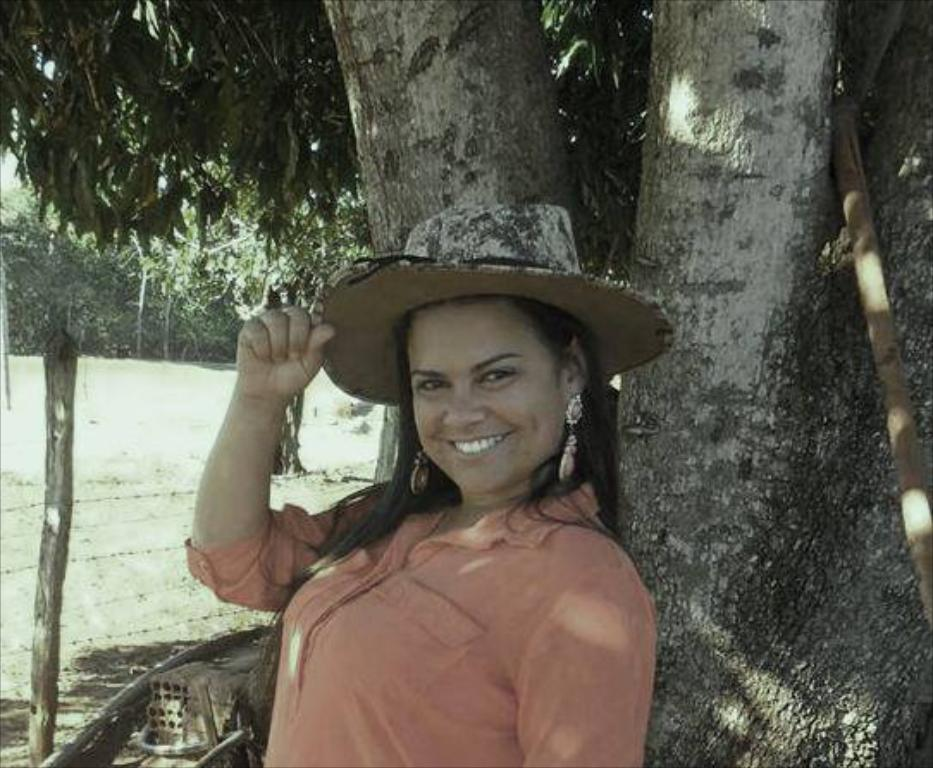Who is the main subject in the image? There is a lady in the center of the image. What is the lady doing in the image? The lady is standing in the image. What expression does the lady have on her face? The lady is smiling in the image. What is the lady wearing on her head? The lady is wearing a hat in the image. What can be seen in the background of the image? There are trees and a fence in the background of the image. How many fingers does the lady's grandfather have in the image? There is no mention of a grandfather or fingers in the image; it only features a lady. 